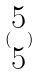<formula> <loc_0><loc_0><loc_500><loc_500>( \begin{matrix} 5 \\ 5 \end{matrix} )</formula> 